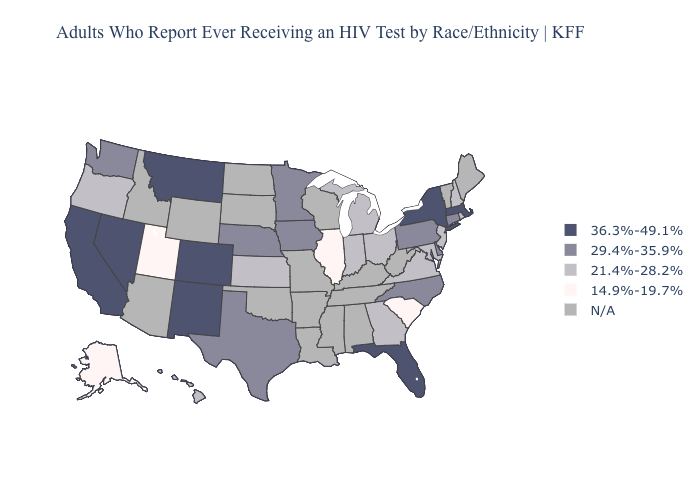Does Utah have the lowest value in the USA?
Give a very brief answer. Yes. Does the first symbol in the legend represent the smallest category?
Short answer required. No. Name the states that have a value in the range N/A?
Keep it brief. Alabama, Arizona, Arkansas, Idaho, Kentucky, Louisiana, Maine, Mississippi, Missouri, North Dakota, Oklahoma, South Dakota, Tennessee, Vermont, West Virginia, Wisconsin, Wyoming. Does Montana have the highest value in the USA?
Concise answer only. Yes. Name the states that have a value in the range N/A?
Quick response, please. Alabama, Arizona, Arkansas, Idaho, Kentucky, Louisiana, Maine, Mississippi, Missouri, North Dakota, Oklahoma, South Dakota, Tennessee, Vermont, West Virginia, Wisconsin, Wyoming. What is the lowest value in the USA?
Short answer required. 14.9%-19.7%. Does Colorado have the highest value in the West?
Give a very brief answer. Yes. Which states hav the highest value in the Northeast?
Be succinct. Massachusetts, New York. Among the states that border Indiana , which have the highest value?
Give a very brief answer. Michigan, Ohio. Does the map have missing data?
Give a very brief answer. Yes. Name the states that have a value in the range 29.4%-35.9%?
Answer briefly. Connecticut, Delaware, Iowa, Minnesota, Nebraska, North Carolina, Pennsylvania, Texas, Washington. Which states have the lowest value in the USA?
Short answer required. Alaska, Illinois, South Carolina, Utah. Which states hav the highest value in the Northeast?
Be succinct. Massachusetts, New York. 